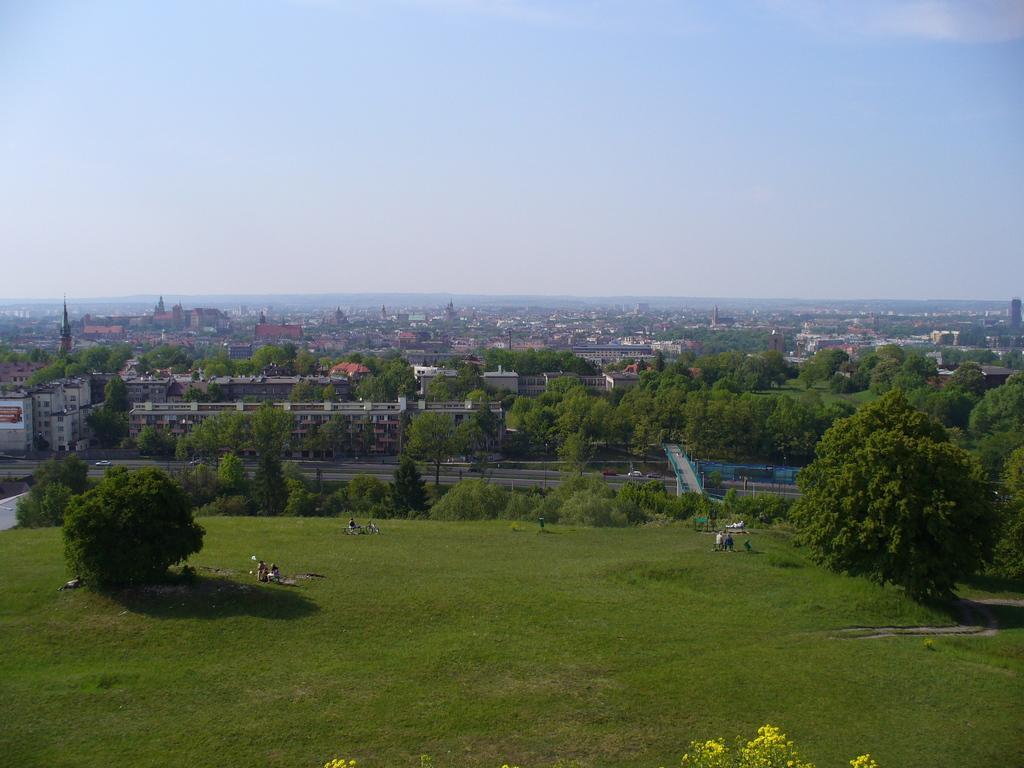How would you summarize this image in a sentence or two? In this image there are trees and we can see buildings, towers, hills and sky. At the bottom there are people and grass. 